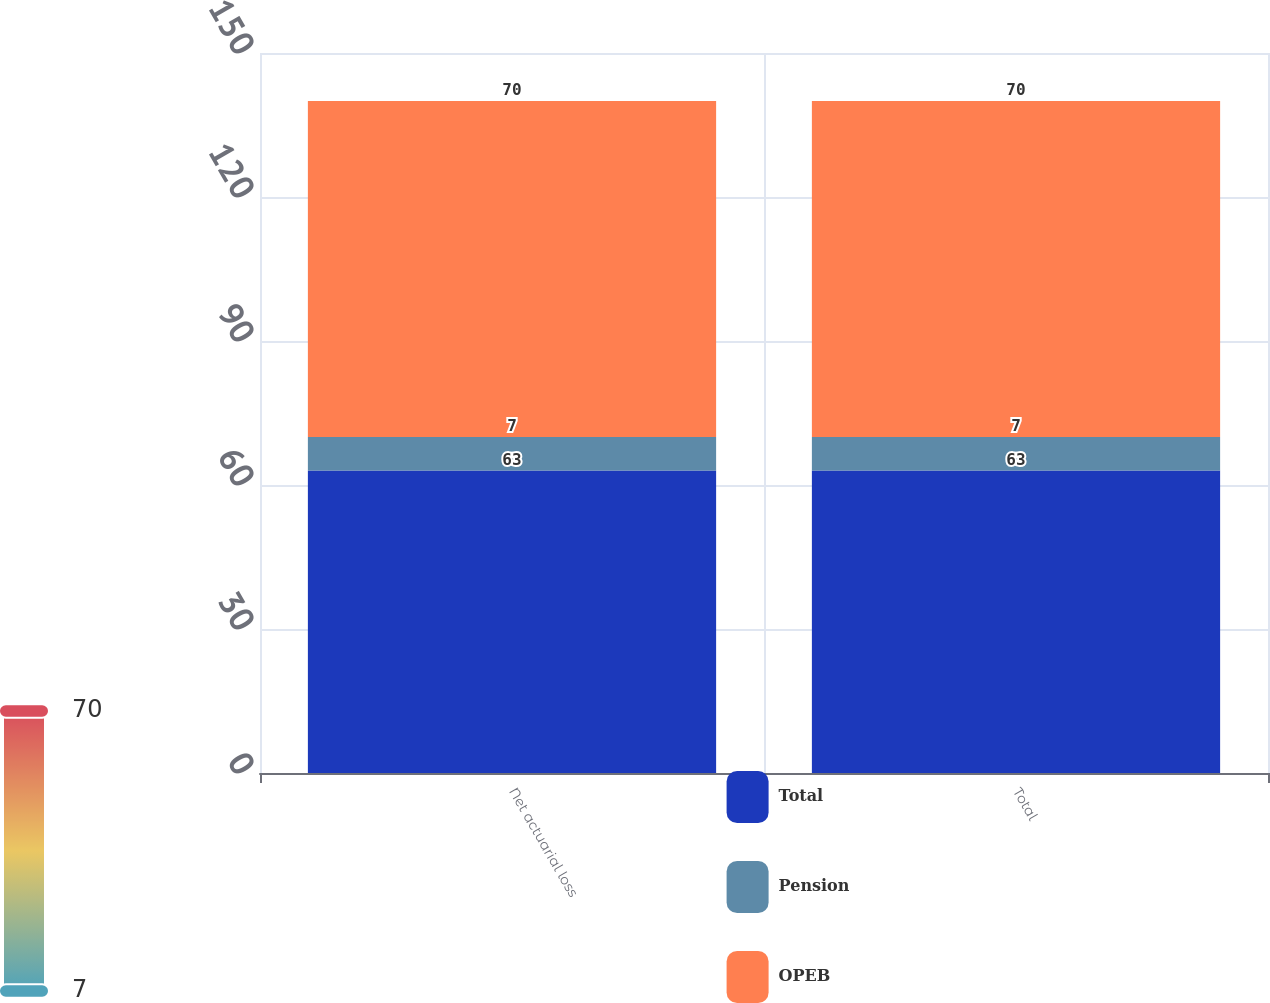<chart> <loc_0><loc_0><loc_500><loc_500><stacked_bar_chart><ecel><fcel>Net actuarial loss<fcel>Total<nl><fcel>Total<fcel>63<fcel>63<nl><fcel>Pension<fcel>7<fcel>7<nl><fcel>OPEB<fcel>70<fcel>70<nl></chart> 